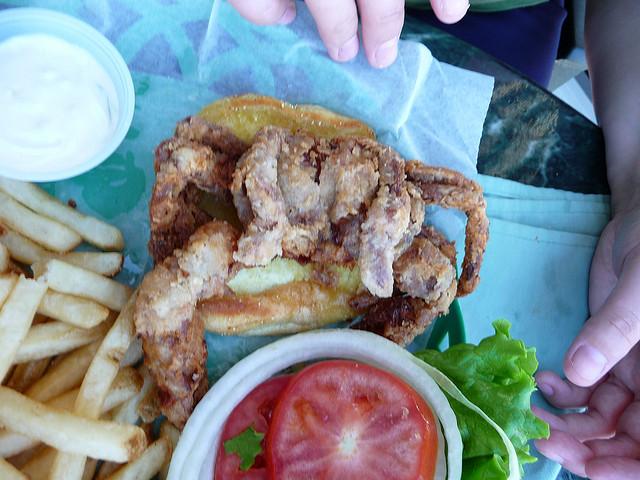Are there fries?
Be succinct. Yes. Are there veggies on the plate?
Answer briefly. Yes. Are there tomatoes on the plate?
Write a very short answer. Yes. 